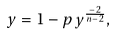Convert formula to latex. <formula><loc_0><loc_0><loc_500><loc_500>y = 1 - p \, y ^ { \frac { - 2 } { n - 2 } } ,</formula> 